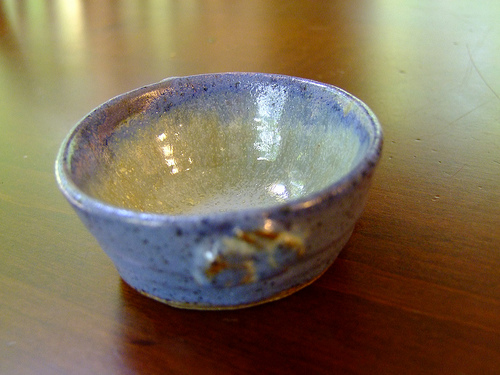<image>
Is the bowl on the table? Yes. Looking at the image, I can see the bowl is positioned on top of the table, with the table providing support. 